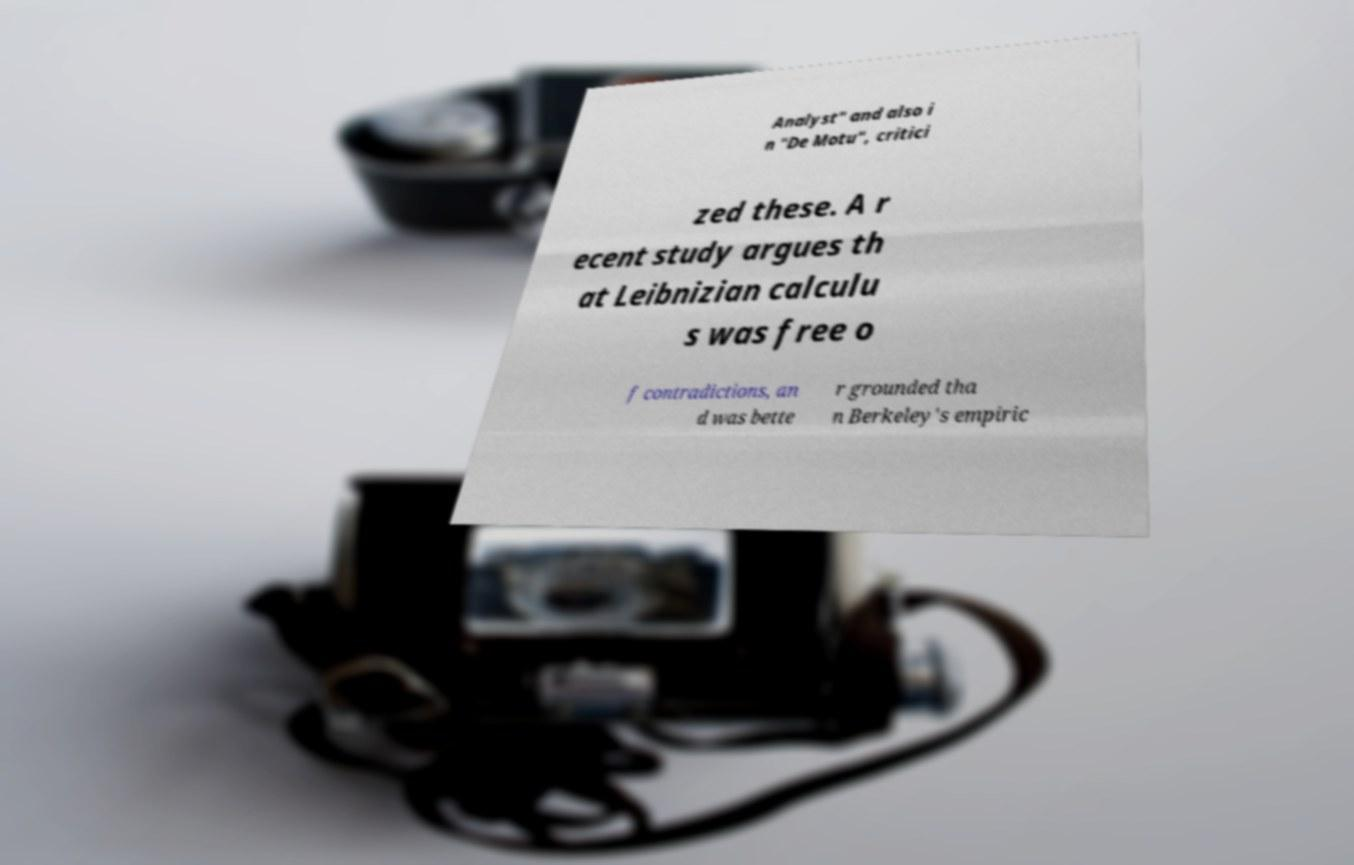Could you extract and type out the text from this image? Analyst" and also i n "De Motu", critici zed these. A r ecent study argues th at Leibnizian calculu s was free o f contradictions, an d was bette r grounded tha n Berkeley's empiric 